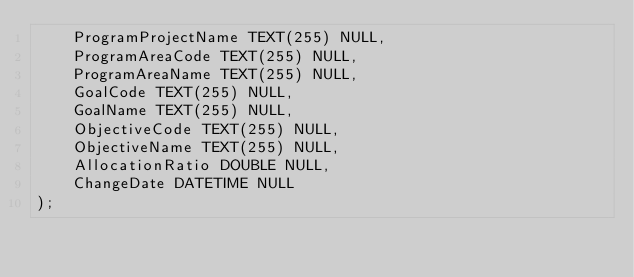Convert code to text. <code><loc_0><loc_0><loc_500><loc_500><_SQL_>	ProgramProjectName TEXT(255) NULL,
	ProgramAreaCode TEXT(255) NULL,
	ProgramAreaName TEXT(255) NULL,
	GoalCode TEXT(255) NULL,
	GoalName TEXT(255) NULL,
	ObjectiveCode TEXT(255) NULL,
	ObjectiveName TEXT(255) NULL,
	AllocationRatio DOUBLE NULL,
	ChangeDate DATETIME NULL
);

</code> 